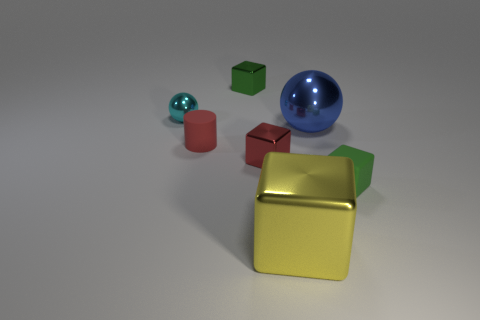The rubber thing on the left side of the small green block that is behind the small rubber cylinder is what shape?
Offer a very short reply. Cylinder. The shiny thing that is the same color as the small cylinder is what size?
Your answer should be compact. Small. There is a large metallic thing that is behind the small green matte object; is its shape the same as the green matte object?
Your answer should be very brief. No. Are there more cyan balls left of the cyan ball than tiny green cubes in front of the green matte object?
Your answer should be very brief. No. There is a tiny green object that is behind the red block; what number of big blue balls are to the right of it?
Make the answer very short. 1. There is a object that is the same color as the tiny rubber cylinder; what is it made of?
Give a very brief answer. Metal. What number of other things are the same color as the cylinder?
Provide a succinct answer. 1. The small matte object behind the small object that is on the right side of the large yellow block is what color?
Offer a very short reply. Red. Are there any matte cylinders that have the same color as the rubber cube?
Your response must be concise. No. How many rubber things are small objects or small cyan spheres?
Keep it short and to the point. 2. 